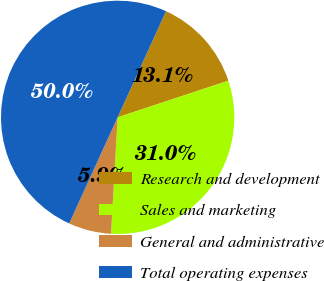Convert chart. <chart><loc_0><loc_0><loc_500><loc_500><pie_chart><fcel>Research and development<fcel>Sales and marketing<fcel>General and administrative<fcel>Total operating expenses<nl><fcel>13.1%<fcel>30.99%<fcel>5.91%<fcel>50.0%<nl></chart> 